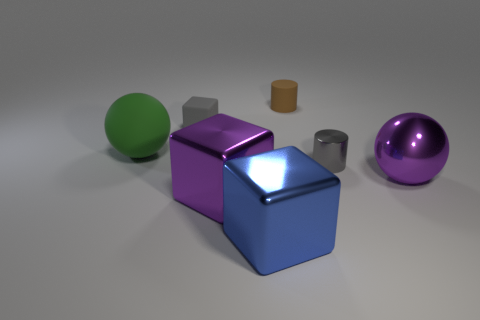There is a large green object that is the same material as the tiny brown cylinder; what is its shape?
Your answer should be very brief. Sphere. Are there any big cubes of the same color as the small block?
Your answer should be very brief. No. How many metallic things are either green cylinders or brown objects?
Offer a very short reply. 0. What number of purple metal objects are in front of the ball that is behind the metal ball?
Give a very brief answer. 2. How many other large green balls have the same material as the green ball?
Provide a short and direct response. 0. What number of large objects are green spheres or blue objects?
Provide a short and direct response. 2. What is the shape of the thing that is behind the large purple shiny sphere and on the right side of the small brown matte object?
Your answer should be very brief. Cylinder. Does the large green object have the same material as the large purple sphere?
Offer a terse response. No. There is a matte sphere that is the same size as the blue block; what is its color?
Provide a short and direct response. Green. What is the color of the big object that is in front of the metallic cylinder and on the left side of the big blue metal thing?
Your answer should be compact. Purple. 